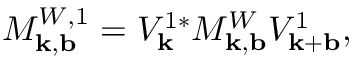Convert formula to latex. <formula><loc_0><loc_0><loc_500><loc_500>M _ { k , b } ^ { W , 1 } = V _ { k } ^ { 1 * } M _ { k , b } ^ { W } V _ { k + b } ^ { 1 } ,</formula> 